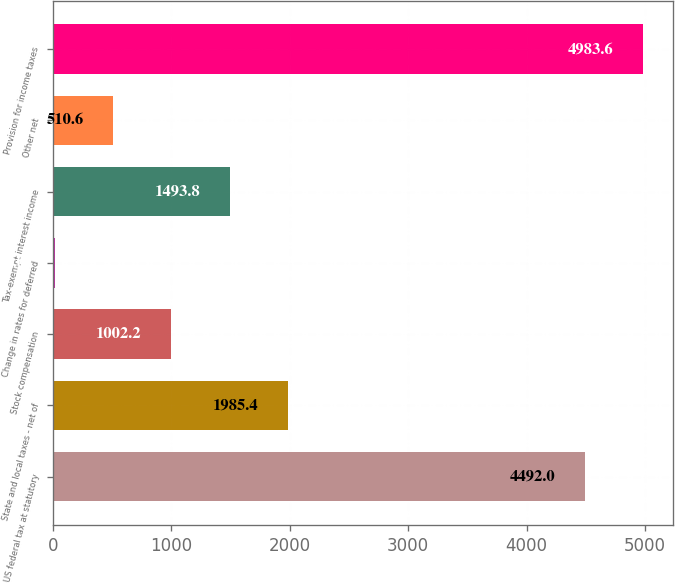<chart> <loc_0><loc_0><loc_500><loc_500><bar_chart><fcel>US federal tax at statutory<fcel>State and local taxes - net of<fcel>Stock compensation<fcel>Change in rates for deferred<fcel>Tax-exempt interest income<fcel>Other net<fcel>Provision for income taxes<nl><fcel>4492<fcel>1985.4<fcel>1002.2<fcel>19<fcel>1493.8<fcel>510.6<fcel>4983.6<nl></chart> 